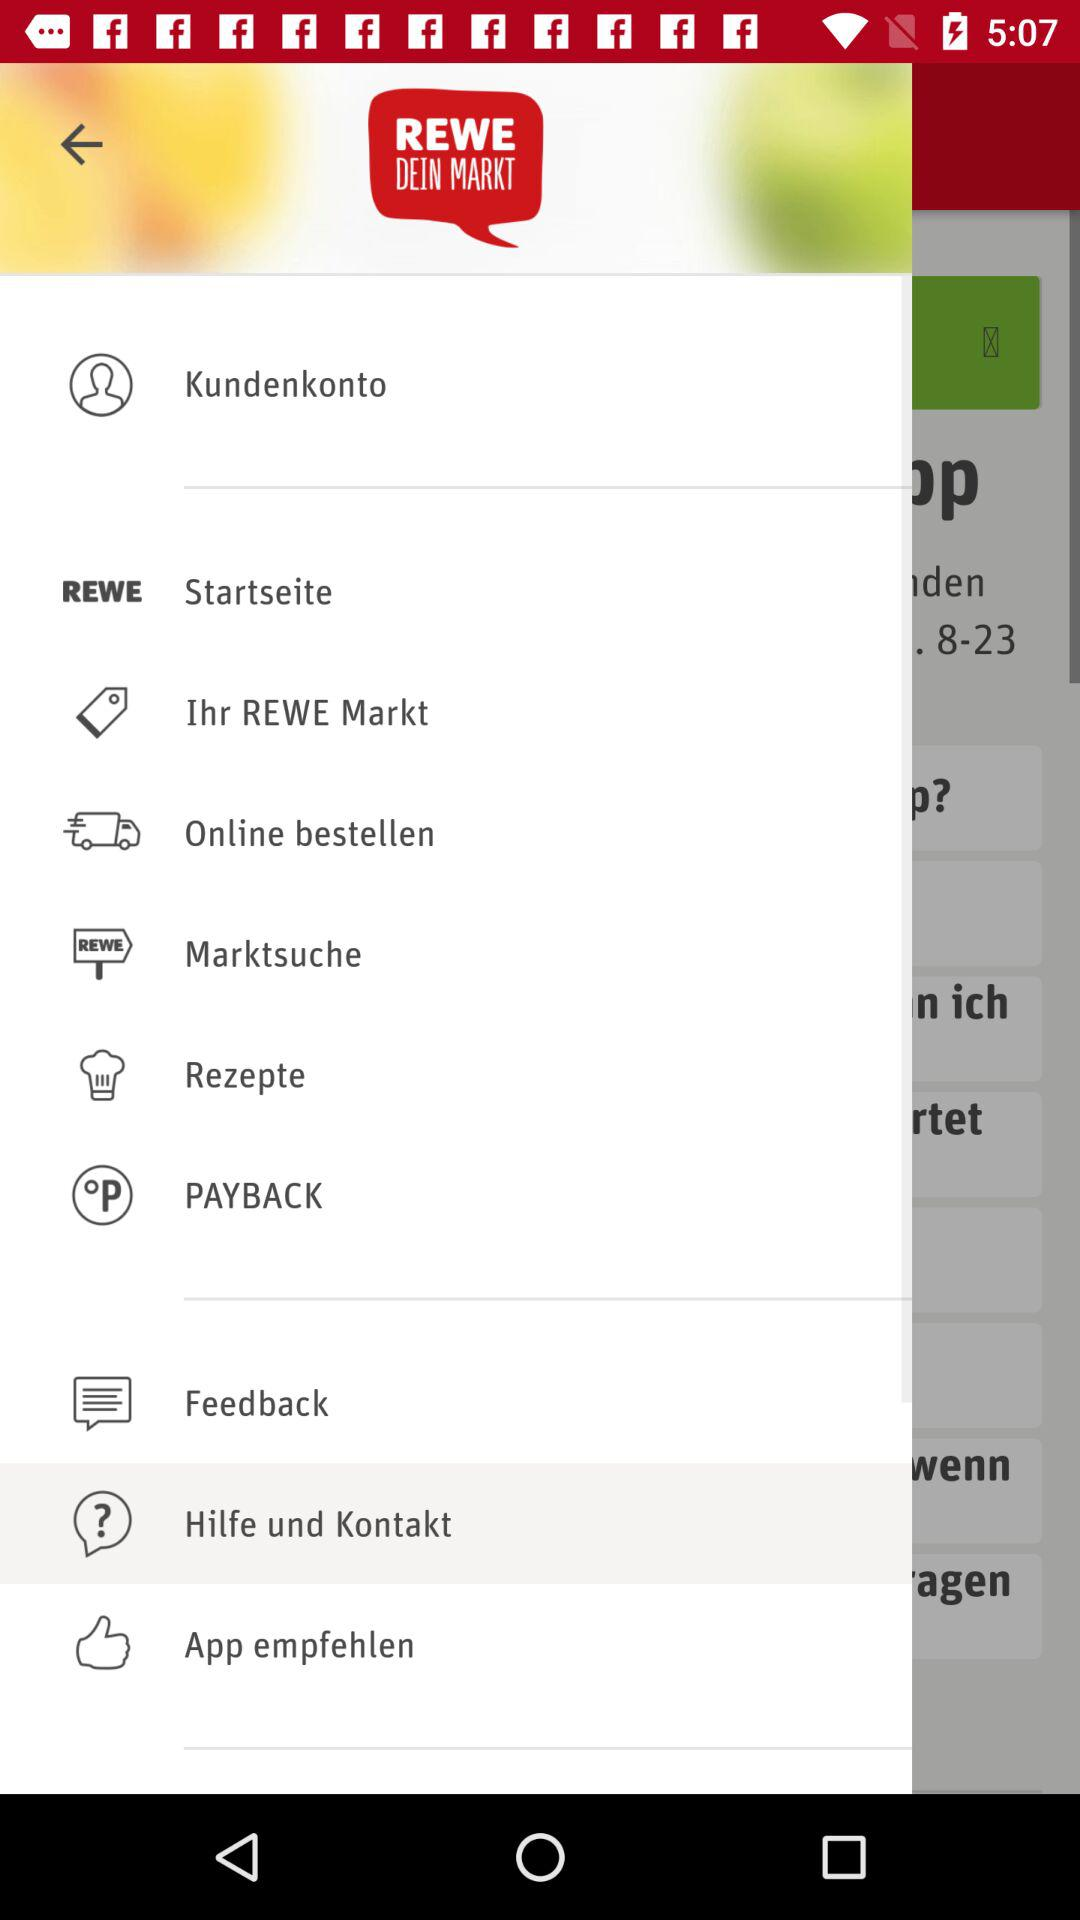Which item is selected? The selected item is "Hilfe und Kontakt". 